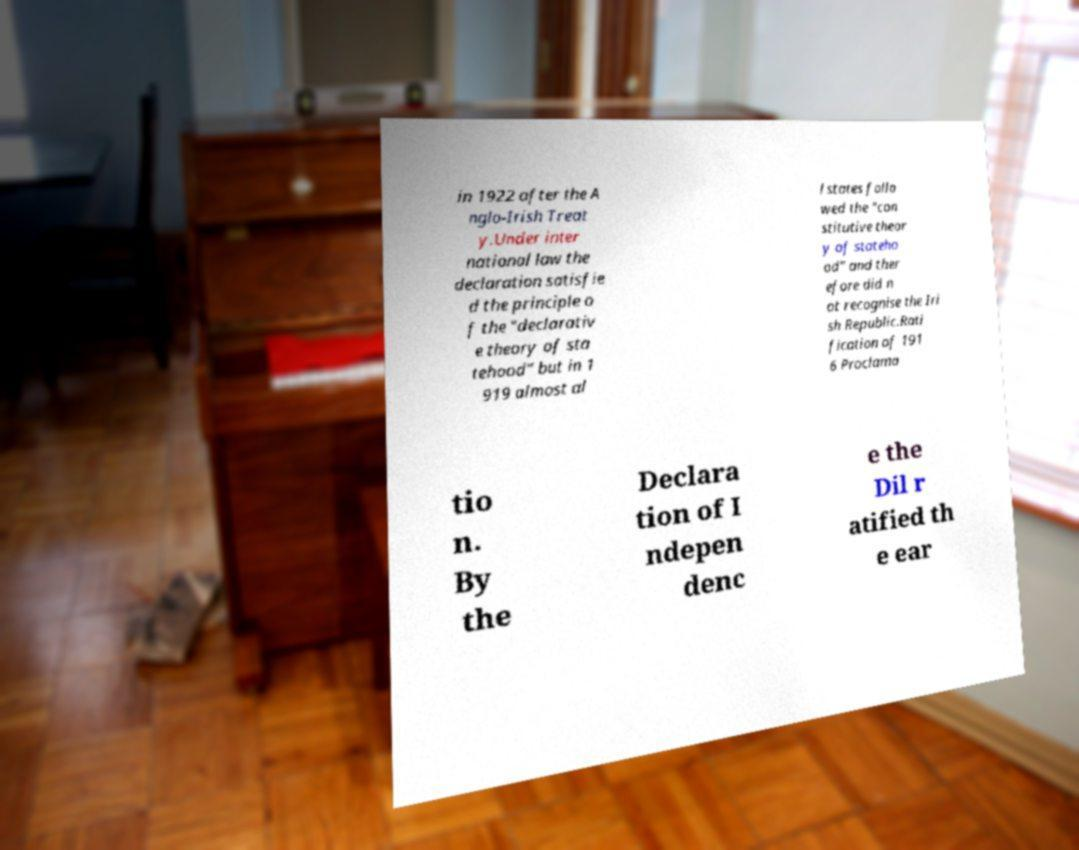Could you extract and type out the text from this image? in 1922 after the A nglo-Irish Treat y.Under inter national law the declaration satisfie d the principle o f the "declarativ e theory of sta tehood" but in 1 919 almost al l states follo wed the "con stitutive theor y of stateho od" and ther efore did n ot recognise the Iri sh Republic.Rati fication of 191 6 Proclama tio n. By the Declara tion of I ndepen denc e the Dil r atified th e ear 